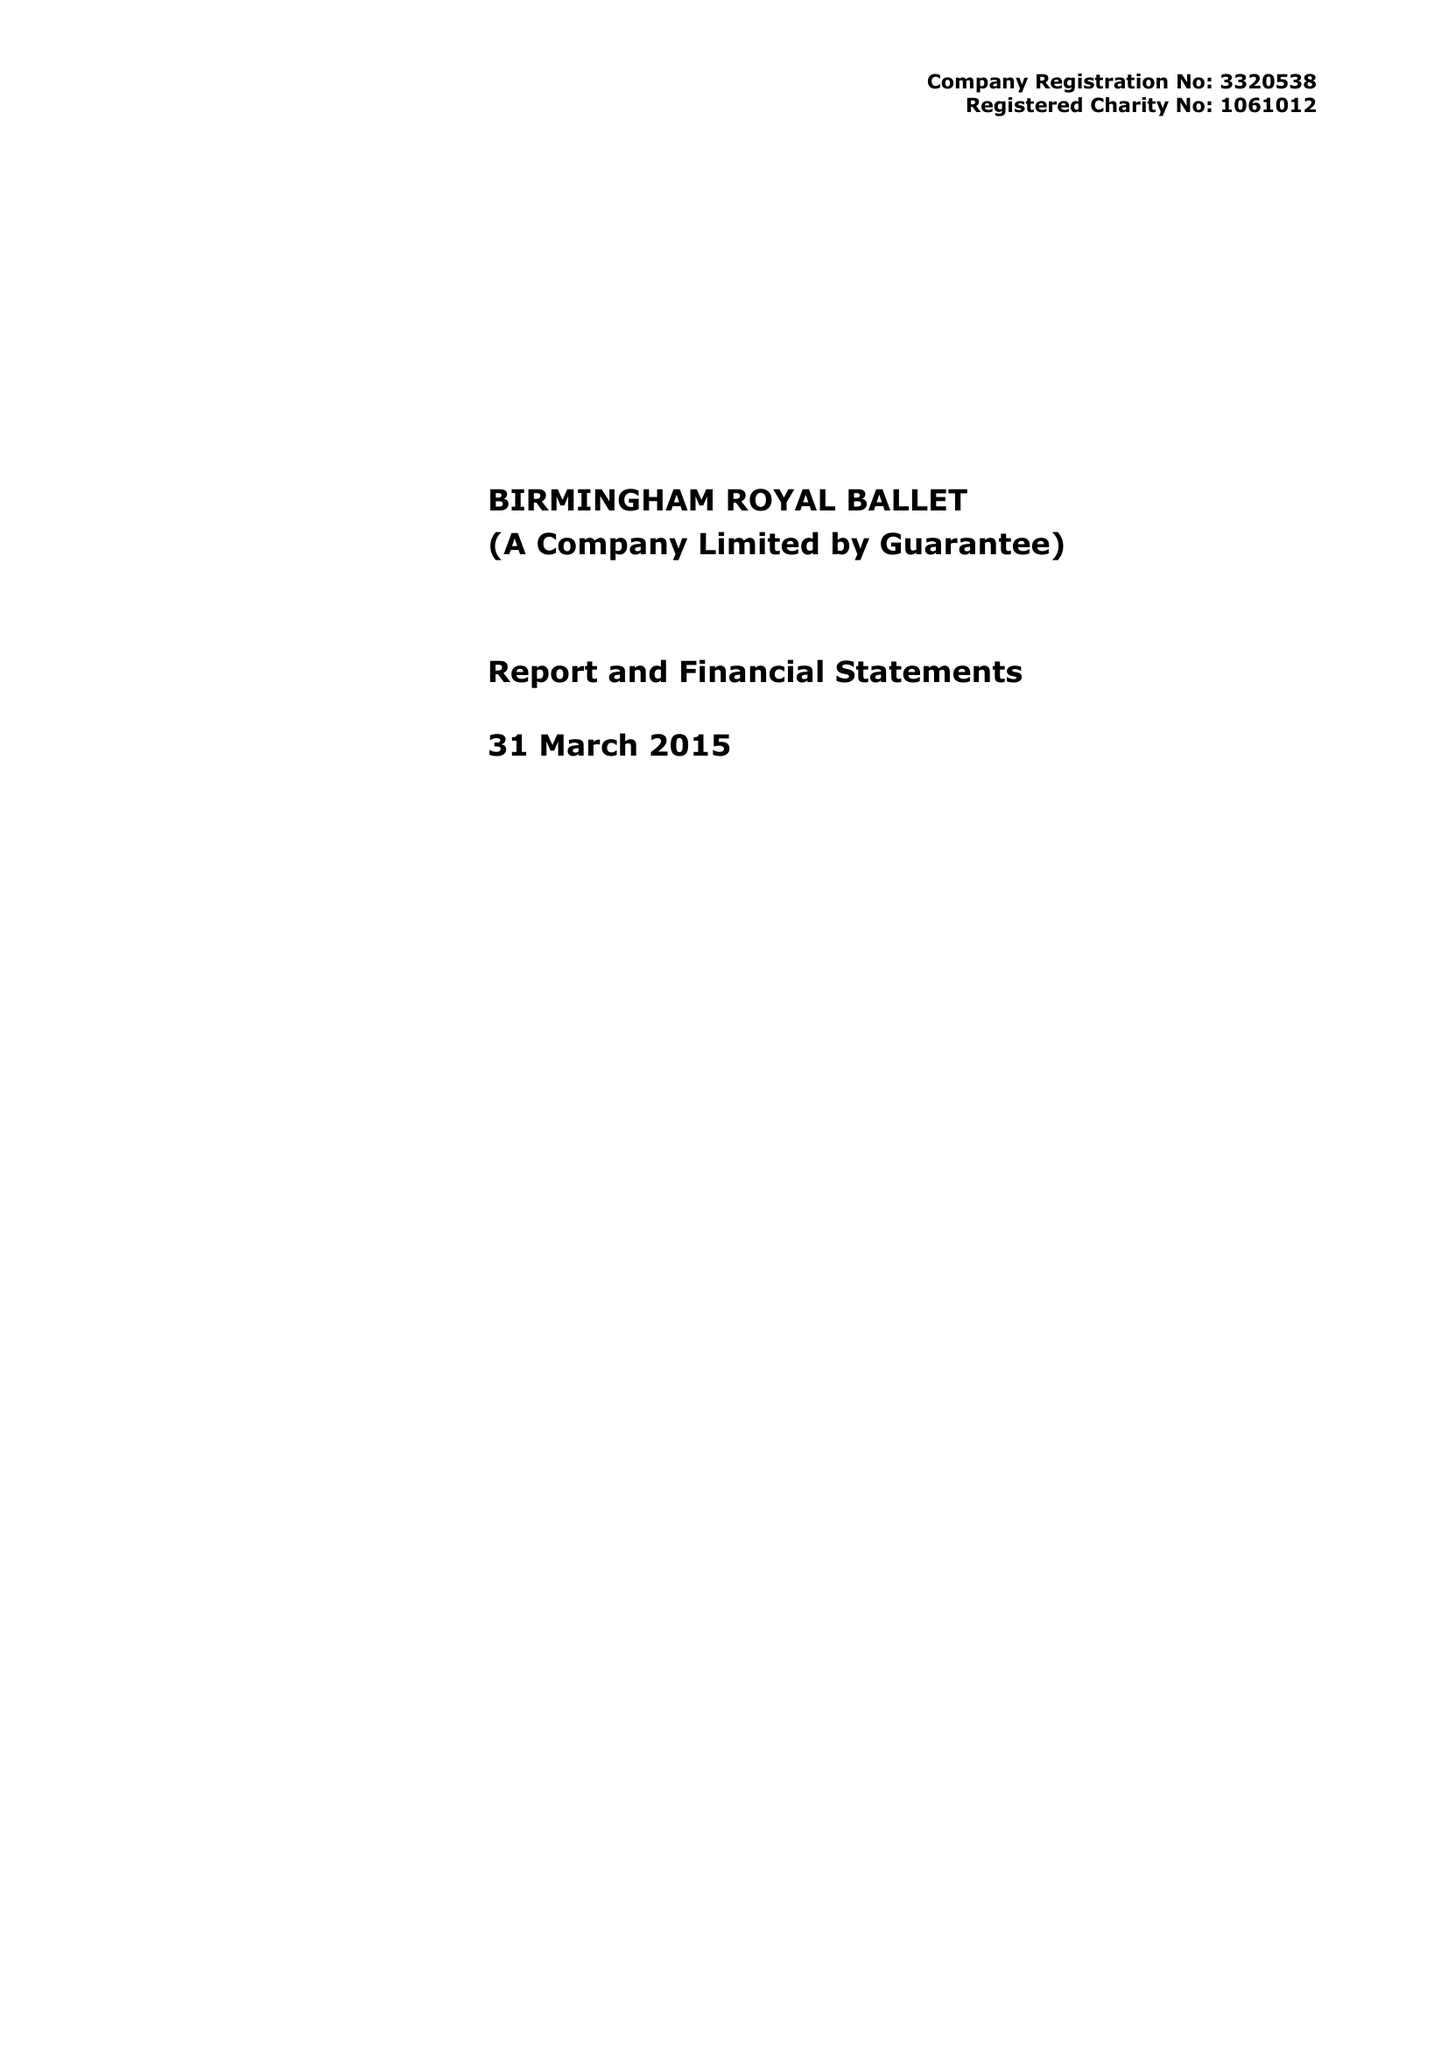What is the value for the report_date?
Answer the question using a single word or phrase. 2015-03-31 